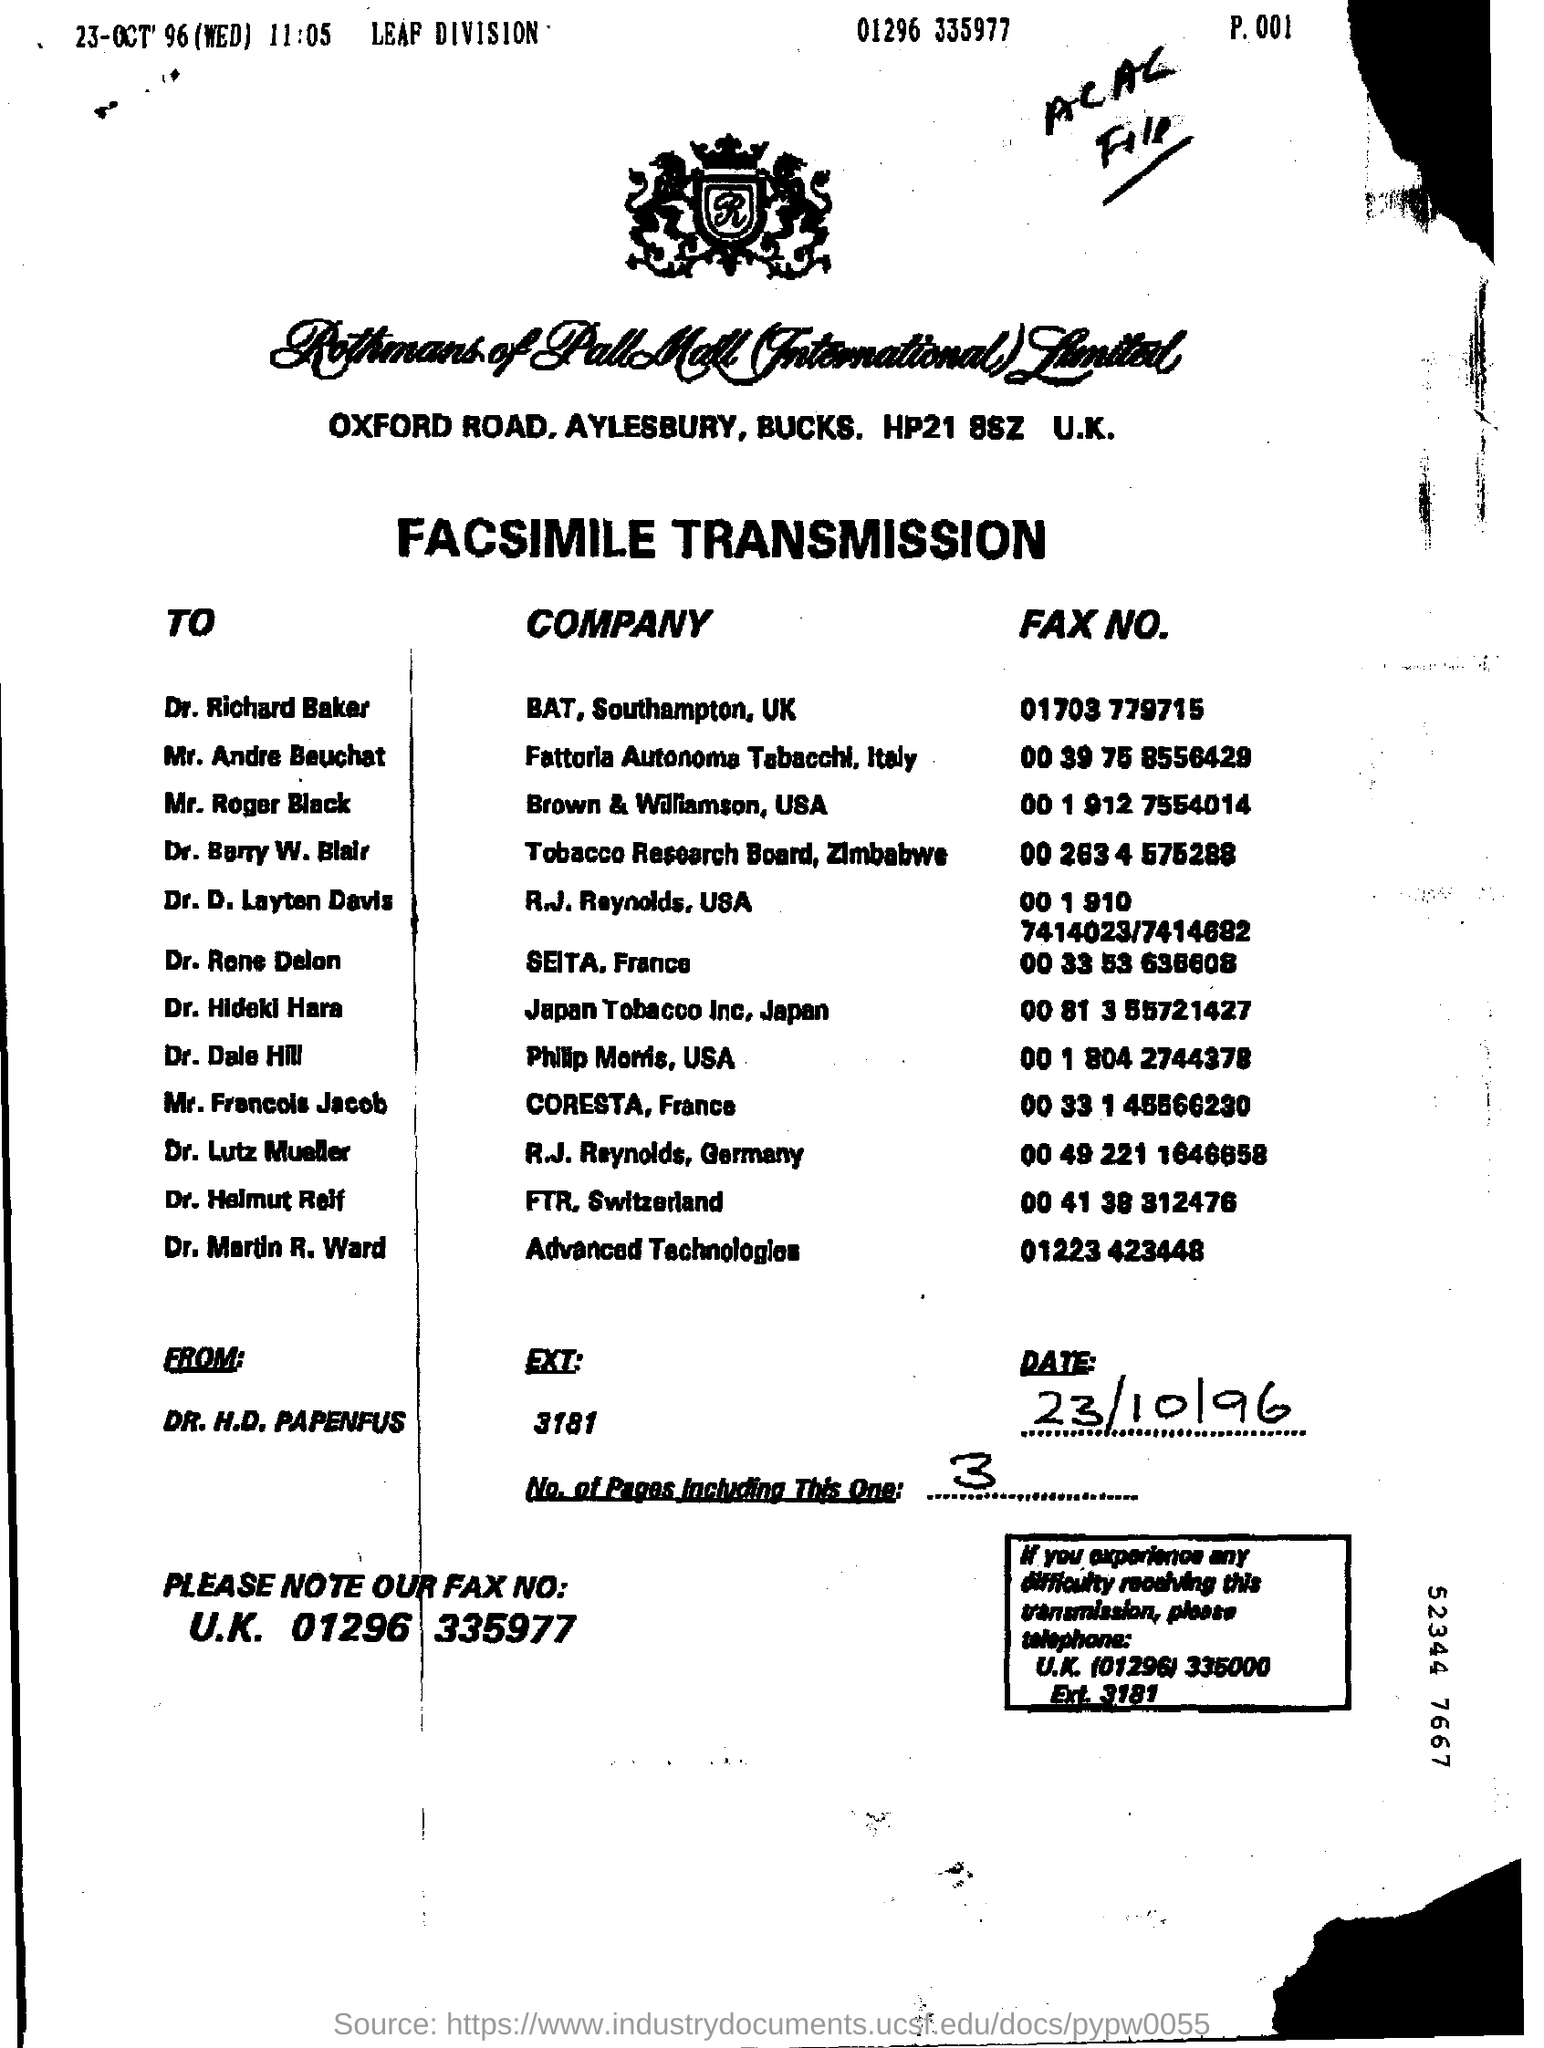Who is this Fax from?
Provide a succinct answer. Dr. H.D. Papenfus. What is the Date?
Offer a terse response. 23/10/96. What is the EXT for Dr. H. D. Papenfus?
Give a very brief answer. 3181. How many Number of Pages including this one?
Your answer should be very brief. 3. What is the Company for Dr. Dale Hill?
Your answer should be compact. Philip Morris,USA. What is the Company for Dr. Martin R. Ward?
Provide a succinct answer. Advanced Technologies. What is the Company for Dr. Barry W. Blair?
Offer a very short reply. Tobacco research board , zimbabwe. What is the Fax No. for Dr. Dale Hill?
Make the answer very short. 00 1 804 2744378. What is the Fax No. for Dr. Martin R. Ward?
Provide a succinct answer. 01223 423448. What is the Fax No. for Dr. Barry W. Blair?
Your answer should be very brief. 00 263 4 575288. 